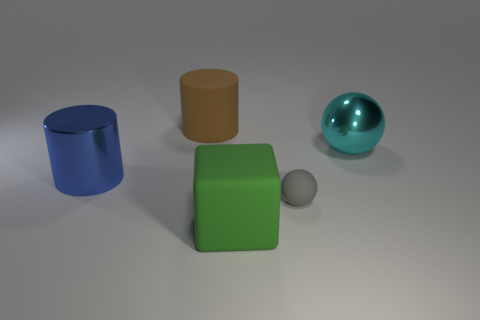Add 4 gray spheres. How many objects exist? 9 Subtract all cylinders. How many objects are left? 3 Add 5 large rubber objects. How many large rubber objects are left? 7 Add 5 gray metal spheres. How many gray metal spheres exist? 5 Subtract 0 brown blocks. How many objects are left? 5 Subtract all cyan metallic objects. Subtract all big brown matte things. How many objects are left? 3 